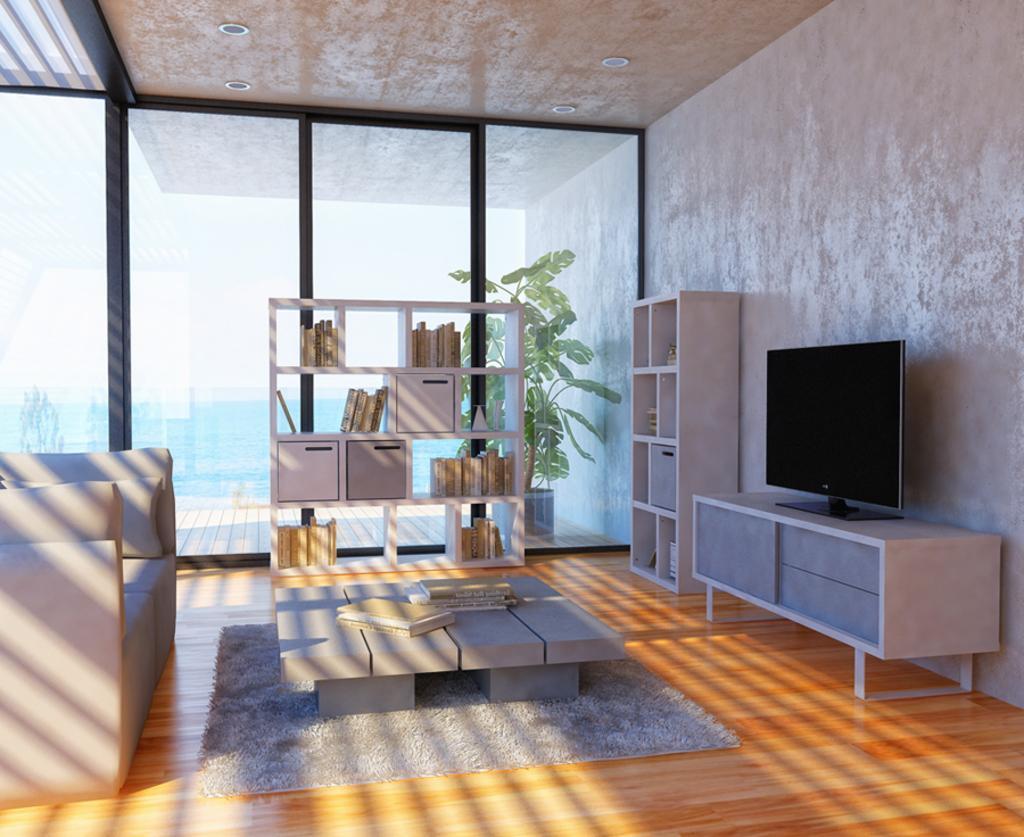Could you give a brief overview of what you see in this image? In the image there is a tv on a table on the right side in front of the wall, in the middle there is a table on the carpet, on the left side there is a sofa, in the back there is a cupboard with books in it with a glass wall behind it and over the back there is a plant. 